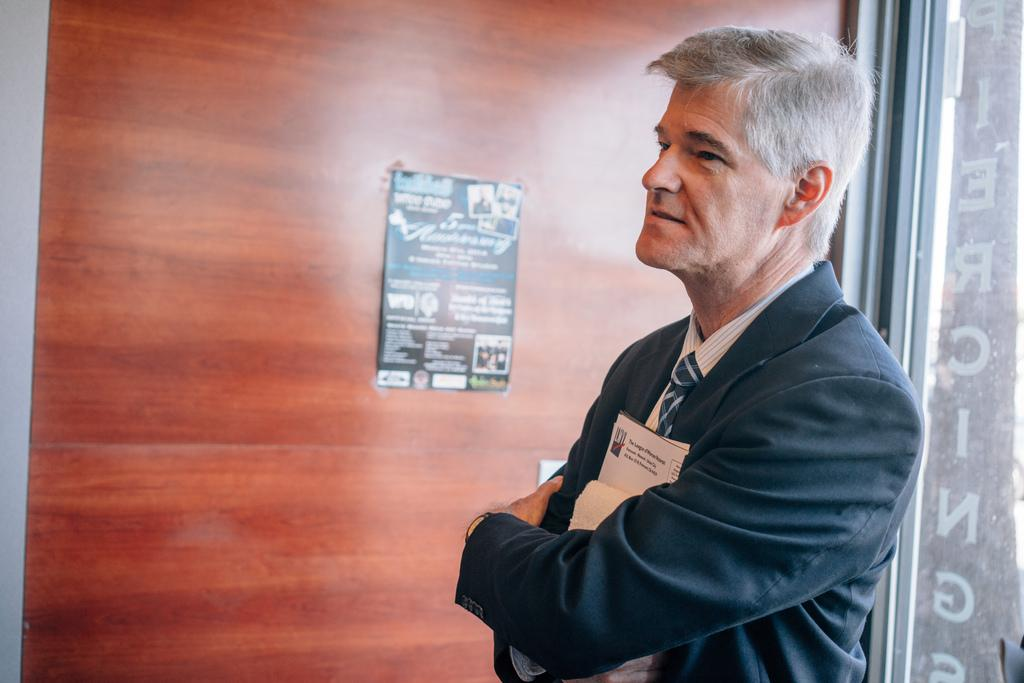What is the person in the image doing? The person is standing in the image. What type of clothing is the person wearing on their upper body? The person is wearing a black blazer and a white shirt. What accessory is the person wearing around their neck? The person is wearing a black and white tie. What is the person holding in their hands? The person is holding papers. What can be seen in the background of the image? There is a wooden wall in the background of the image. What is the price of the fly that is resting on the person's shoulder in the image? There is no fly present on the person's shoulder in the image. How is the string used by the person in the image? There is no string visible in the image. 